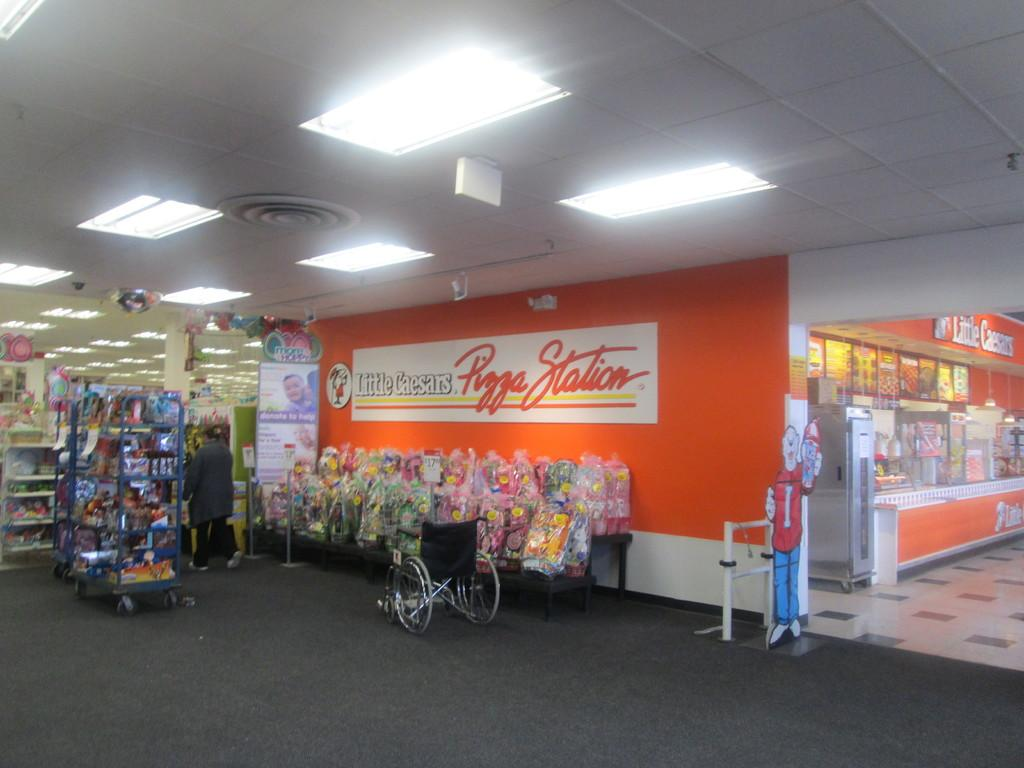<image>
Render a clear and concise summary of the photo. the inside of a mall in front of a Little Caesars Pizza Station 